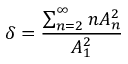<formula> <loc_0><loc_0><loc_500><loc_500>\delta = { \frac { \sum _ { n = 2 } ^ { \infty } n A _ { n } ^ { 2 } } { A _ { 1 } ^ { 2 } } }</formula> 